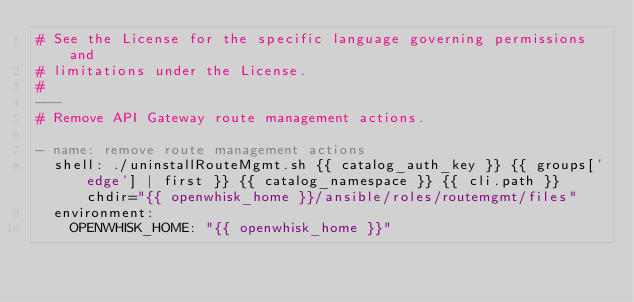<code> <loc_0><loc_0><loc_500><loc_500><_YAML_># See the License for the specific language governing permissions and
# limitations under the License.
#
---
# Remove API Gateway route management actions.

- name: remove route management actions
  shell: ./uninstallRouteMgmt.sh {{ catalog_auth_key }} {{ groups['edge'] | first }} {{ catalog_namespace }} {{ cli.path }} chdir="{{ openwhisk_home }}/ansible/roles/routemgmt/files"
  environment:
    OPENWHISK_HOME: "{{ openwhisk_home }}"
</code> 